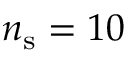Convert formula to latex. <formula><loc_0><loc_0><loc_500><loc_500>n _ { s } = 1 0</formula> 